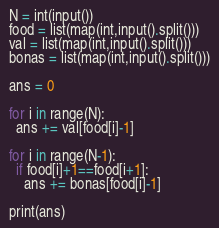Convert code to text. <code><loc_0><loc_0><loc_500><loc_500><_Python_>N = int(input())
food = list(map(int,input().split()))
val = list(map(int,input().split()))
bonas = list(map(int,input().split()))

ans = 0

for i in range(N):
  ans += val[food[i]-1]
  
for i in range(N-1):
  if food[i]+1==food[i+1]:
    ans += bonas[food[i]-1]
    
print(ans)</code> 